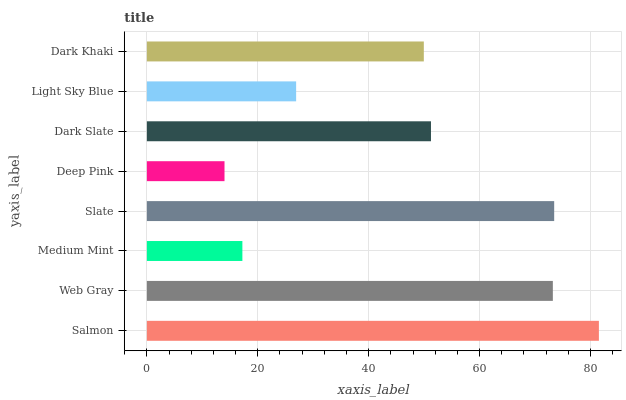Is Deep Pink the minimum?
Answer yes or no. Yes. Is Salmon the maximum?
Answer yes or no. Yes. Is Web Gray the minimum?
Answer yes or no. No. Is Web Gray the maximum?
Answer yes or no. No. Is Salmon greater than Web Gray?
Answer yes or no. Yes. Is Web Gray less than Salmon?
Answer yes or no. Yes. Is Web Gray greater than Salmon?
Answer yes or no. No. Is Salmon less than Web Gray?
Answer yes or no. No. Is Dark Slate the high median?
Answer yes or no. Yes. Is Dark Khaki the low median?
Answer yes or no. Yes. Is Deep Pink the high median?
Answer yes or no. No. Is Deep Pink the low median?
Answer yes or no. No. 